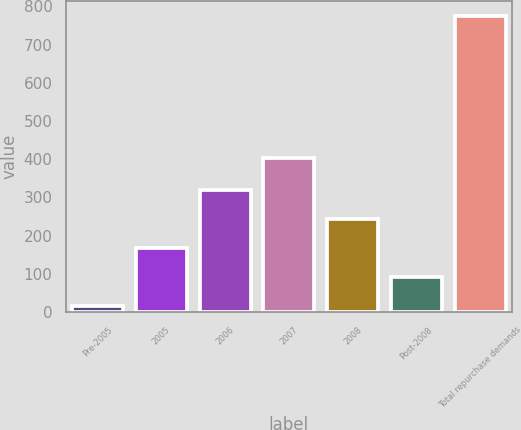Convert chart to OTSL. <chart><loc_0><loc_0><loc_500><loc_500><bar_chart><fcel>Pre-2005<fcel>2005<fcel>2006<fcel>2007<fcel>2008<fcel>Post-2008<fcel>Total repurchase demands<nl><fcel>16<fcel>168<fcel>320<fcel>403<fcel>244<fcel>92<fcel>776<nl></chart> 